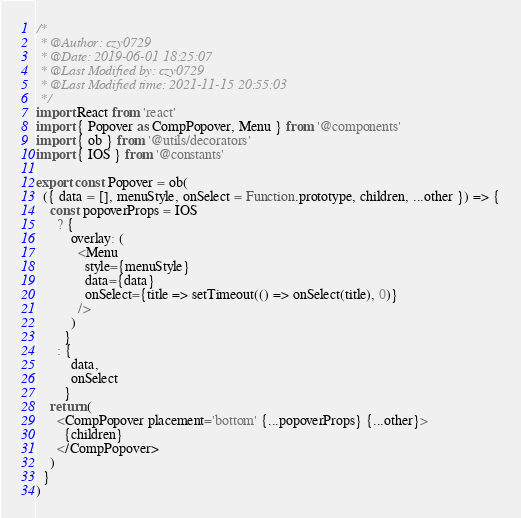<code> <loc_0><loc_0><loc_500><loc_500><_JavaScript_>/*
 * @Author: czy0729
 * @Date: 2019-06-01 18:25:07
 * @Last Modified by: czy0729
 * @Last Modified time: 2021-11-15 20:55:03
 */
import React from 'react'
import { Popover as CompPopover, Menu } from '@components'
import { ob } from '@utils/decorators'
import { IOS } from '@constants'

export const Popover = ob(
  ({ data = [], menuStyle, onSelect = Function.prototype, children, ...other }) => {
    const popoverProps = IOS
      ? {
          overlay: (
            <Menu
              style={menuStyle}
              data={data}
              onSelect={title => setTimeout(() => onSelect(title), 0)}
            />
          )
        }
      : {
          data,
          onSelect
        }
    return (
      <CompPopover placement='bottom' {...popoverProps} {...other}>
        {children}
      </CompPopover>
    )
  }
)
</code> 